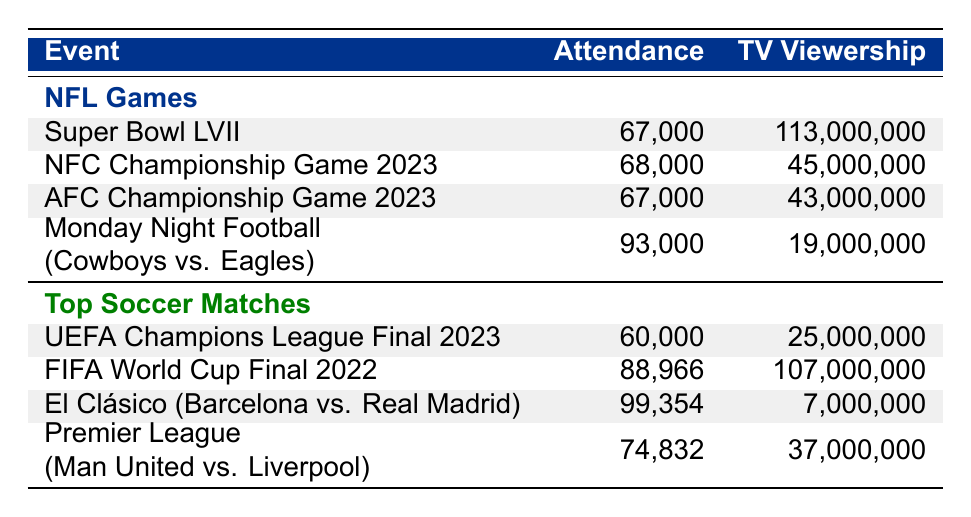What is the attendance of the Super Bowl LVII? The attendance figure is listed directly under the Super Bowl LVII row in the table. That value is 67,000.
Answer: 67,000 What is the TV viewership for the FIFA World Cup Final 2022? The viewership value appears directly in the row for the FIFA World Cup Final 2022 in the table, which is 107,000,000.
Answer: 107,000,000 Which NFL game had the highest attendance? To find this, I compare the attendance figures of all NFL games listed. The highest attendance is observed in the "Monday Night Football - Dallas Cowboys vs. Philadelphia Eagles" with 93,000.
Answer: Monday Night Football - Dallas Cowboys vs. Philadelphia Eagles Which soccer match had the lowest TV viewership? By analyzing the TV viewership figures for the top soccer matches, I see that the "El Clásico: FC Barcelona vs. Real Madrid" had the lowest figure at 7,000,000.
Answer: El Clásico: FC Barcelona vs. Real Madrid What is the average attendance for NFL games listed in the table? First, I add the attendance figures from the four NFL games: 67,000 + 68,000 + 67,000 + 93,000 = 295,000. There are 4 games, so the average is 295,000 / 4 = 73,750.
Answer: 73,750 Is it true that the NFC Championship Game 2023 had more TV viewership than the Premier League match between Manchester United and Liverpool? The TV viewership for the NFC Championship Game is 45,000,000, and for the Premier League match, it is 37,000,000. Since 45,000,000 is greater than 37,000,000, the statement is true.
Answer: Yes What is the difference in TV viewership between the Super Bowl LVII and the NFC Championship Game 2023? The viewership for the Super Bowl LVII is 113,000,000 and for the NFC Championship Game 2023 is 45,000,000. To find the difference, I subtract: 113,000,000 - 45,000,000 = 68,000,000.
Answer: 68,000,000 Which event had the highest attendance: the AFC Championship Game 2023 or the UEFA Champions League Final 2023? The attendance for the AFC Championship Game is 67,000 and for the UEFA Champions League Final is 60,000. Comparing these numbers shows that 67,000 is greater than 60,000.
Answer: AFC Championship Game 2023 What is the total TV viewership for all the NFL games? I need to add the viewership values for all NFL games: 113,000,000 + 45,000,000 + 43,000,000 + 19,000,000 = 220,000,000.
Answer: 220,000,000 Which event had greater TV viewership: Monday Night Football or El Clásico? The TV viewership for Monday Night Football is 19,000,000, and for El Clásico, it is 7,000,000. Since 19,000,000 is greater than 7,000,000, Monday Night Football had more viewership.
Answer: Monday Night Football 